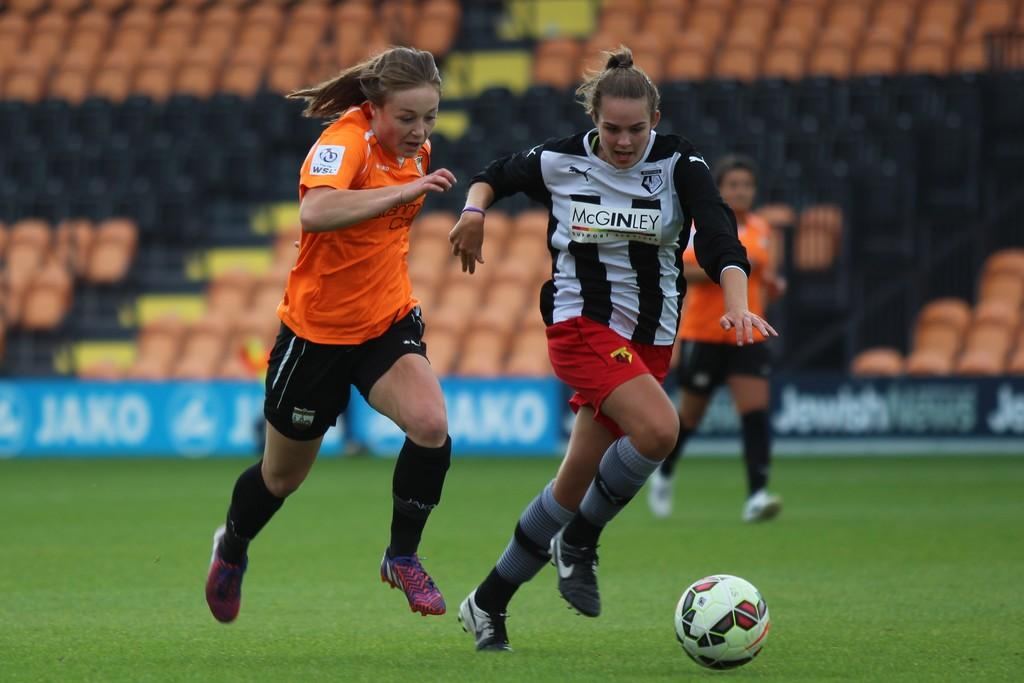<image>
Give a short and clear explanation of the subsequent image. A woman in a soccer uniform that says McGinley competes with another woman. 